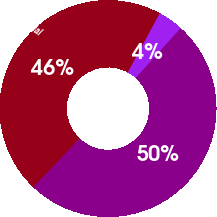<chart> <loc_0><loc_0><loc_500><loc_500><pie_chart><fcel>Auction rate securities (b)<fcel>Derivative financial<fcel>Total<nl><fcel>3.8%<fcel>45.81%<fcel>50.39%<nl></chart> 